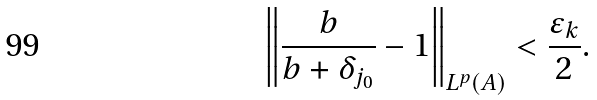Convert formula to latex. <formula><loc_0><loc_0><loc_500><loc_500>\left \| \frac { b } { b + \delta _ { j _ { 0 } } } - 1 \right \| _ { L ^ { p } ( A ) } < \frac { \varepsilon _ { k } } { 2 } .</formula> 